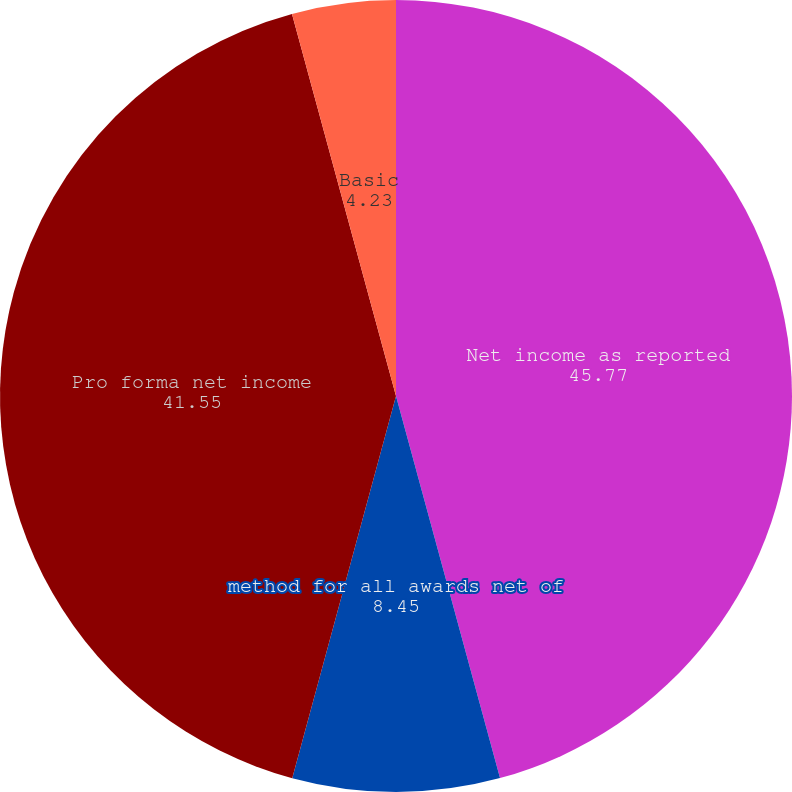Convert chart to OTSL. <chart><loc_0><loc_0><loc_500><loc_500><pie_chart><fcel>Net income as reported<fcel>method for all awards net of<fcel>Pro forma net income<fcel>Basic<fcel>Diluted<nl><fcel>45.77%<fcel>8.45%<fcel>41.55%<fcel>4.23%<fcel>0.0%<nl></chart> 